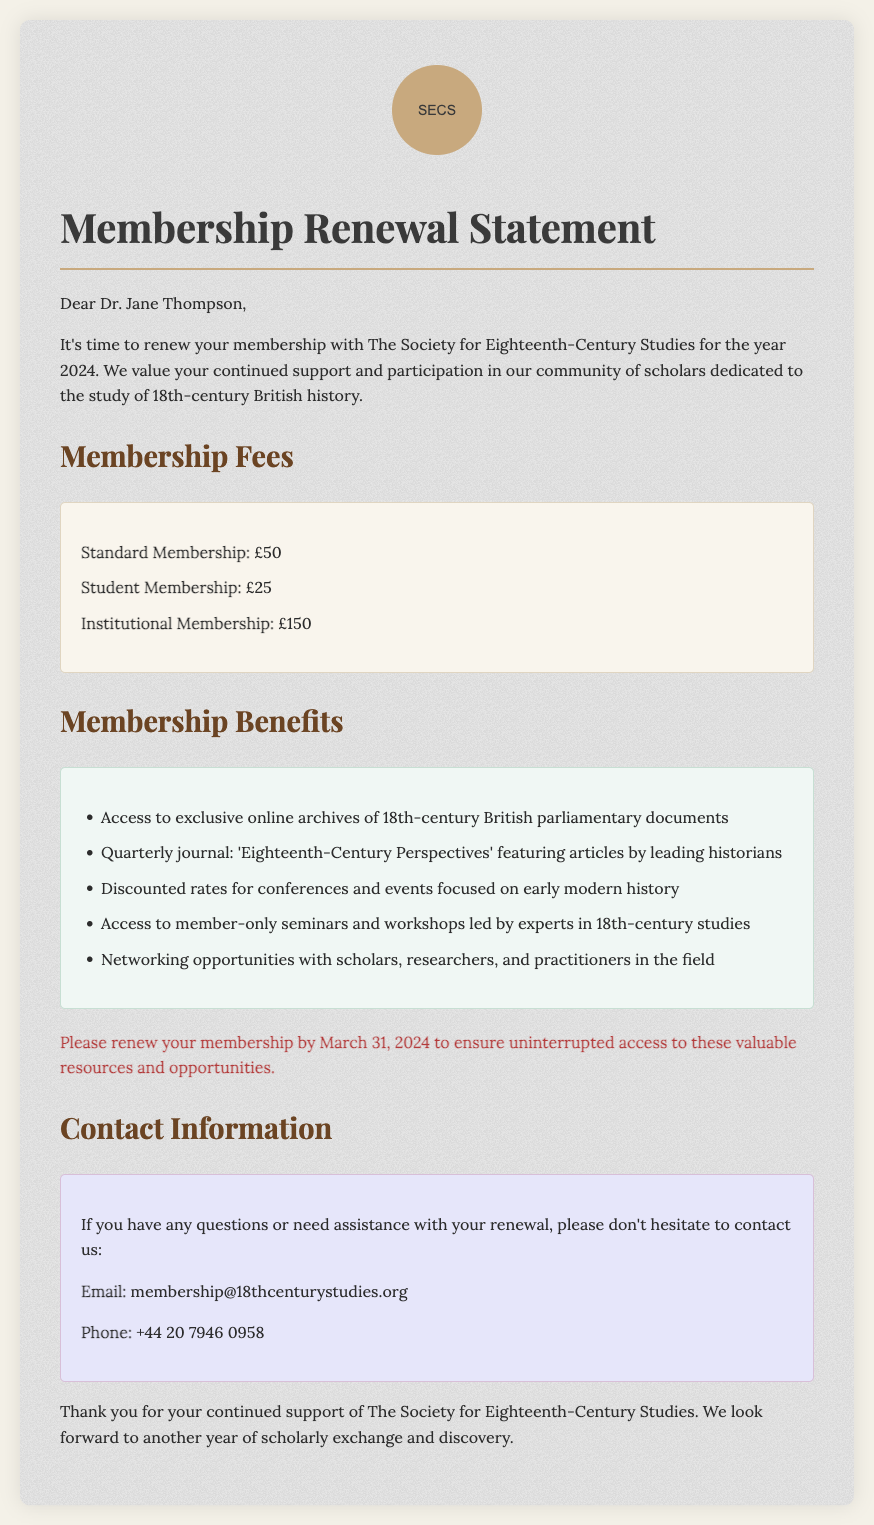What is the standard membership fee? The standard membership fee is listed under "Membership Fees" in the document.
Answer: £50 What is the deadline for membership renewal? The deadline for renewal is mentioned in the text, specifying the date.
Answer: March 31, 2024 What is included in the membership benefits? The membership benefits are outlined in the "Membership Benefits" section of the document, listing several advantages.
Answer: Access to exclusive online archives of 18th-century British parliamentary documents Who is the letter addressed to? The recipient's name is given at the beginning of the document.
Answer: Dr. Jane Thompson What is the institutional membership fee? The fee for institutional membership is presented in the list of fees.
Answer: £150 What type of document is this? The overall purpose and context of the document can be discerned from its title and content.
Answer: Membership Renewal Statement Which journal is mentioned in the benefits? The name of the journal appears in the benefits section of the document.
Answer: 'Eighteenth-Century Perspectives' What contact method is provided for assistance? The document includes a section dedicated to contact information, specifying how to reach out for help.
Answer: Email How many different membership types are listed? The total count of different membership types can be derived from the information in the fees section.
Answer: Three 